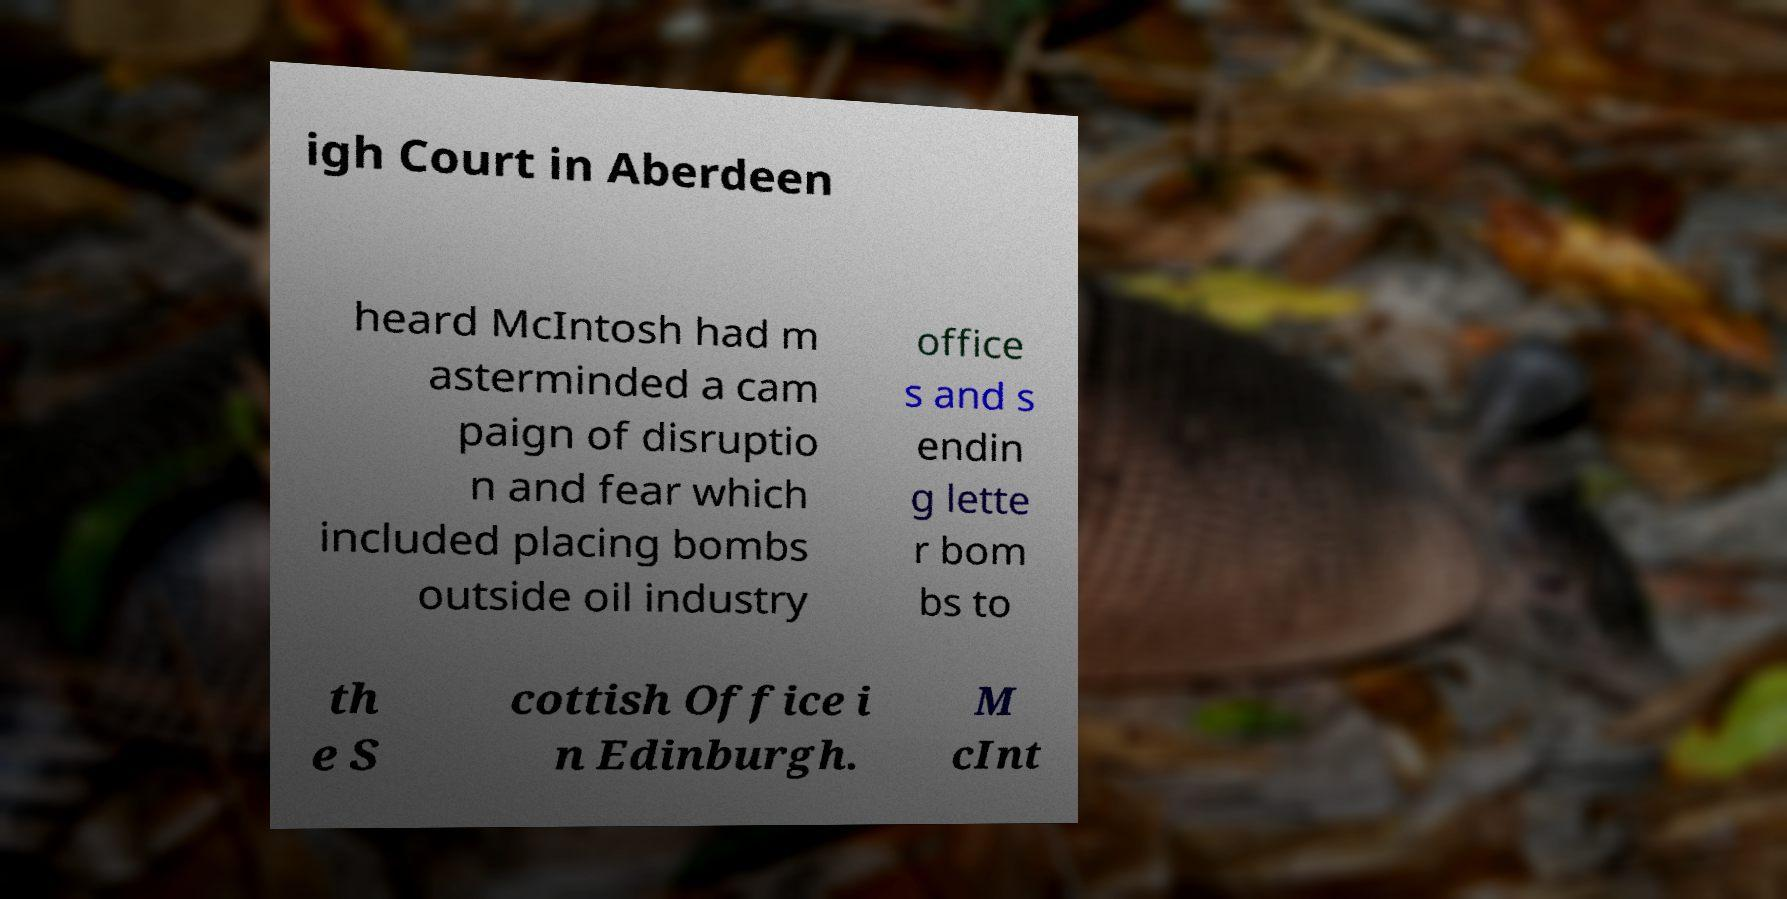Could you extract and type out the text from this image? igh Court in Aberdeen heard McIntosh had m asterminded a cam paign of disruptio n and fear which included placing bombs outside oil industry office s and s endin g lette r bom bs to th e S cottish Office i n Edinburgh. M cInt 